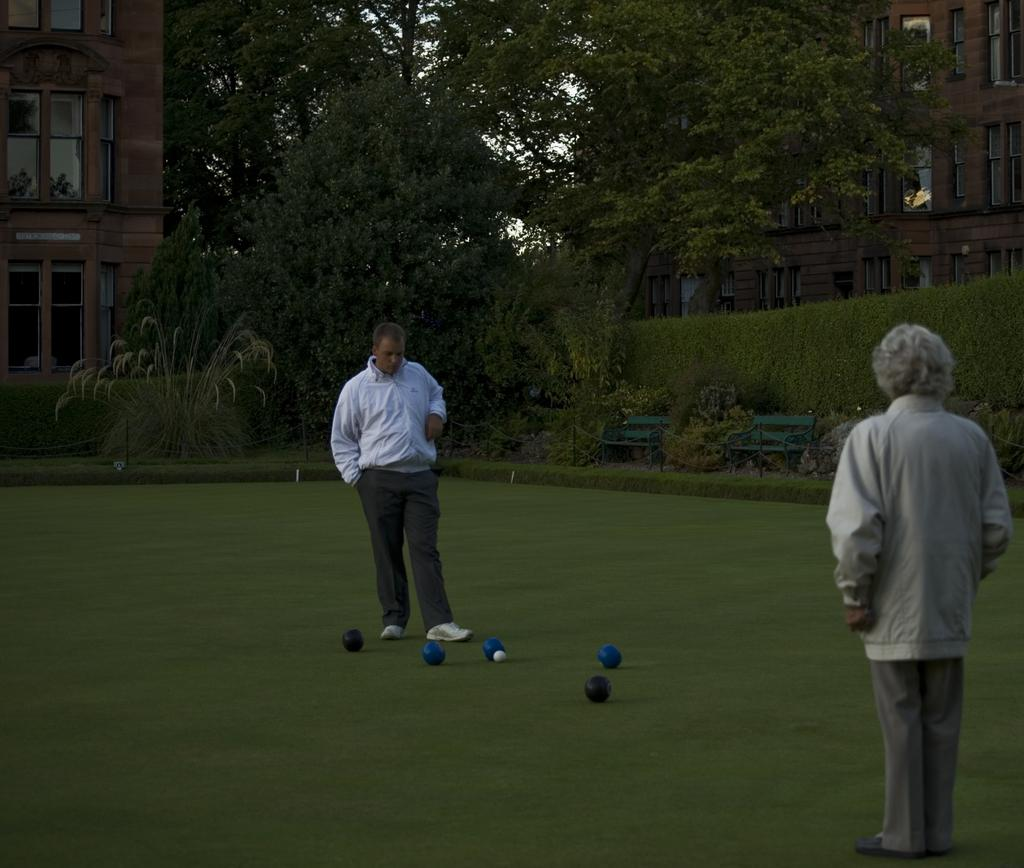How many people are in the image? There are two persons in the image. What is the setting of the image? The image features objects on a grassy land. What can be seen in the background of the image? Trees and buildings are visible in the background of the image. What type of clouds can be seen in the image? There are no clouds visible in the image; it features a grassy land with objects and people. Is there a fireman present in the image? There is no fireman present in the image. 